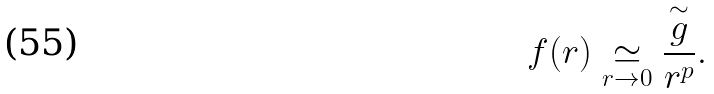Convert formula to latex. <formula><loc_0><loc_0><loc_500><loc_500>f ( r ) \underset { r \rightarrow 0 } { \simeq } \frac { \overset { \sim } { g } } { r ^ { p } } .</formula> 